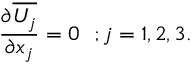<formula> <loc_0><loc_0><loc_500><loc_500>{ \frac { \partial \overline { { U _ { j } } } } { \partial x _ { j } } } = 0 ; j = 1 , 2 , 3 .</formula> 